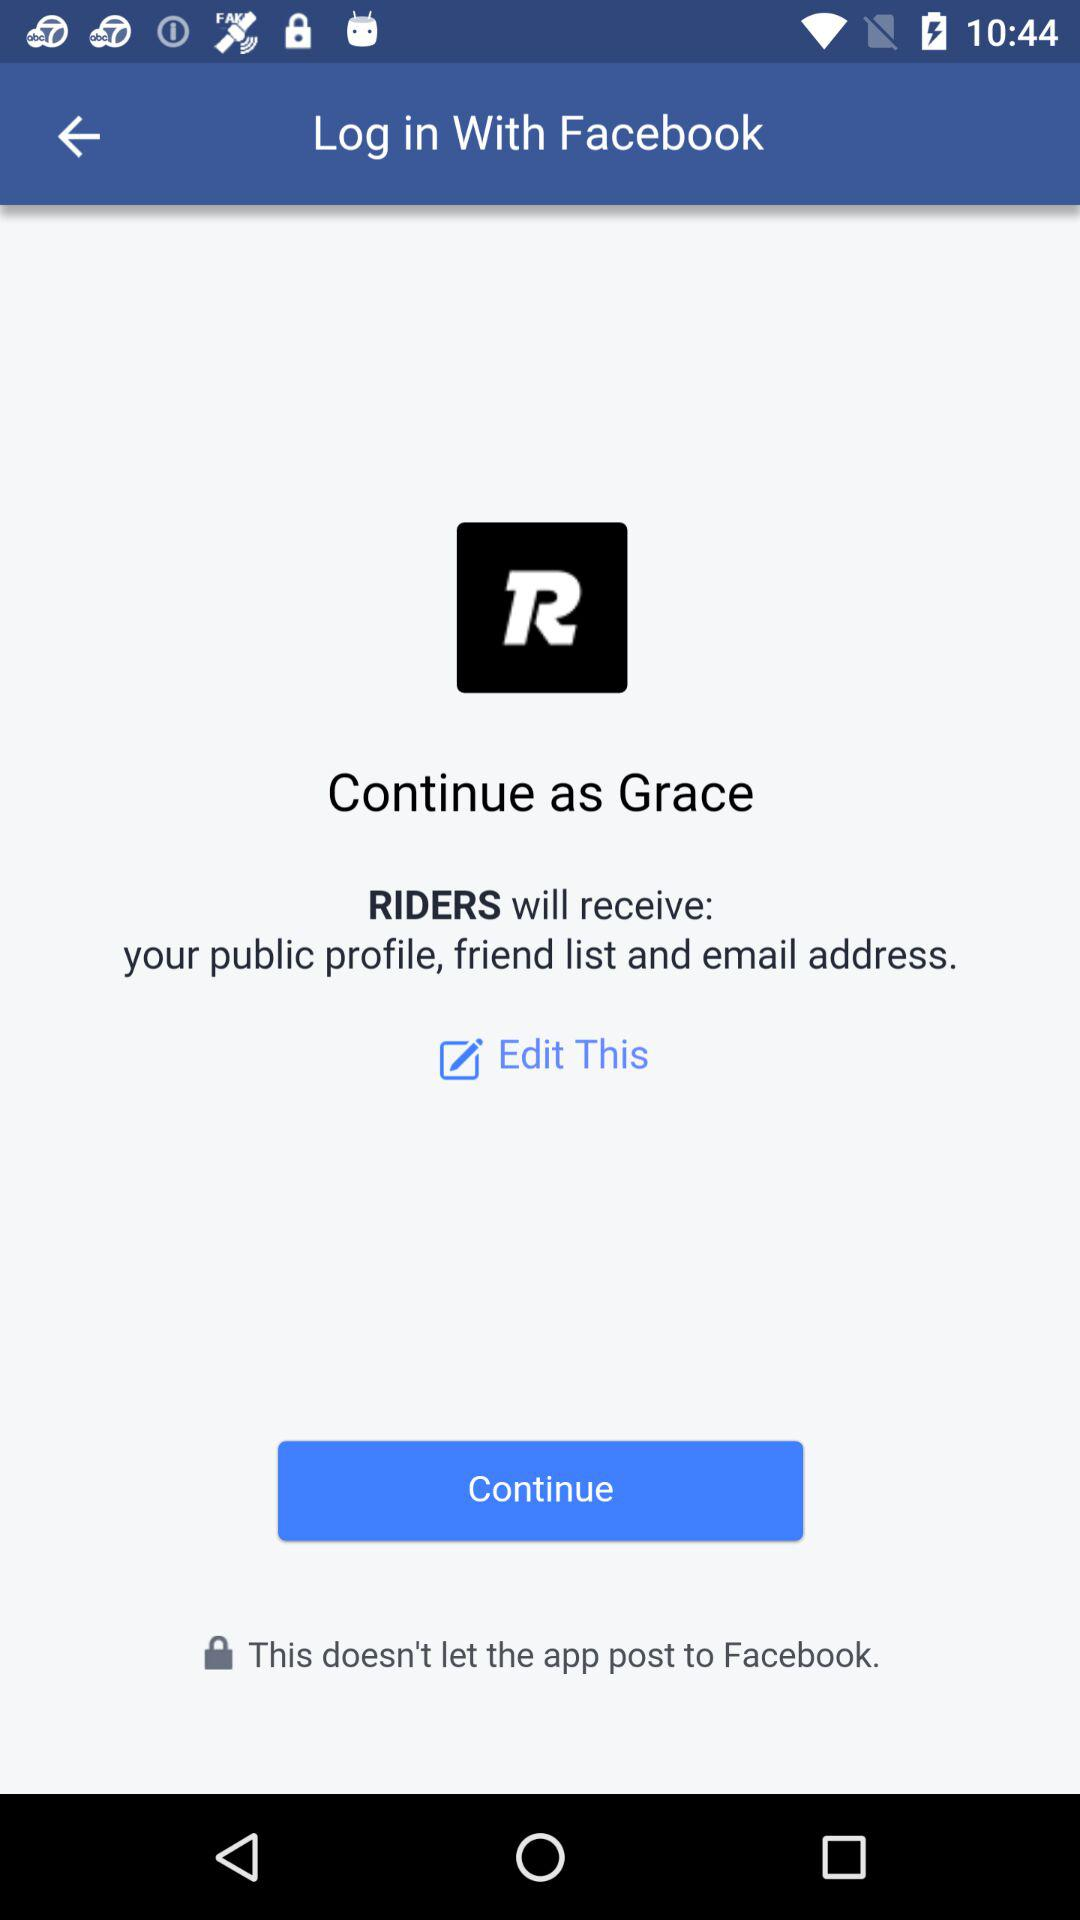What is the username? The username is Grace. 